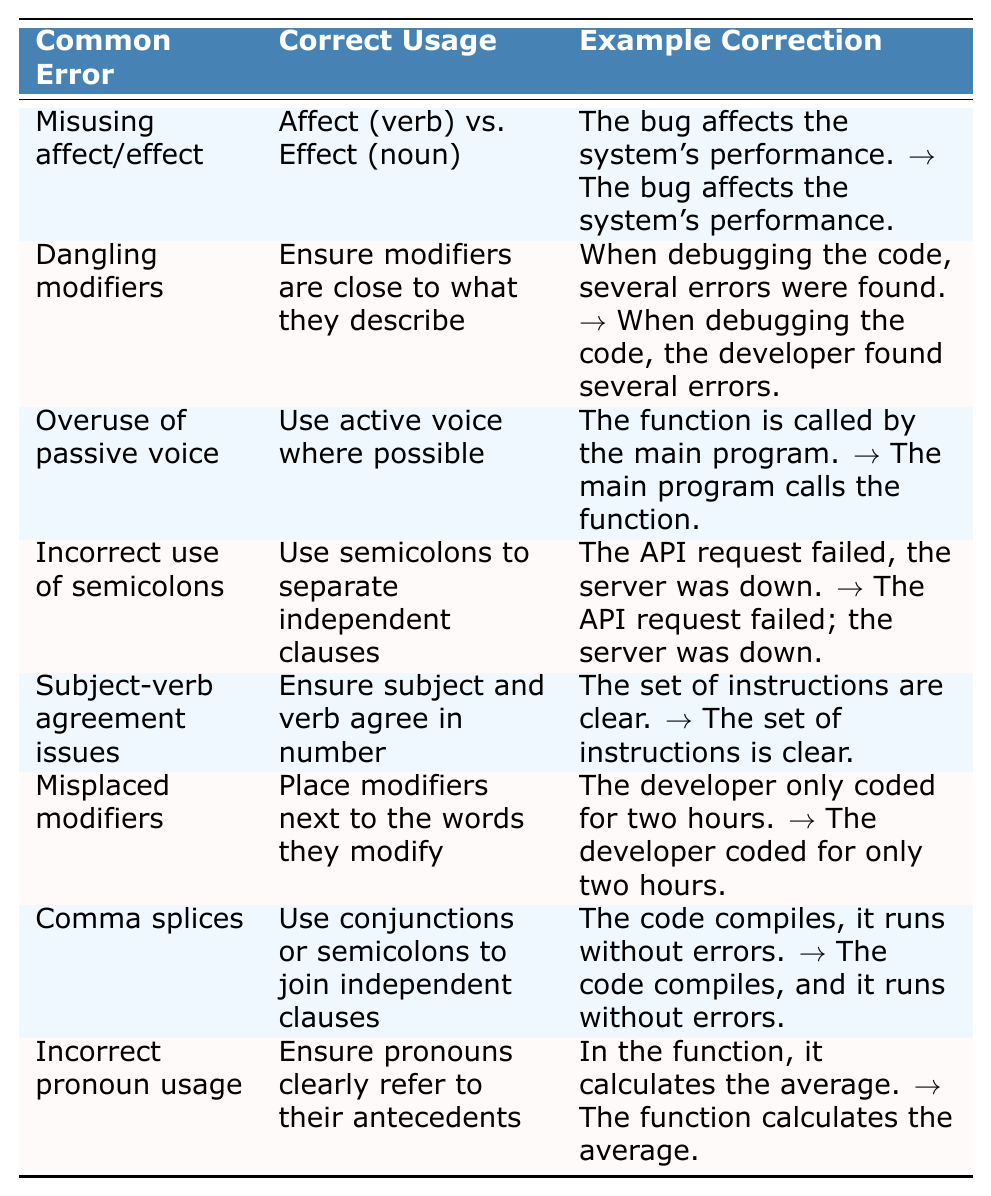What is the common error associated with using "affect" and "effect"? The table lists "Misusing affect/effect" as the common error related to these terms.
Answer: Misusing affect/effect What is the correct usage for dangling modifiers? The table indicates that the correct usage is to ensure modifiers are close to what they describe.
Answer: Ensure modifiers are close to what they describe Which error addresses the issues with subject-verb agreement? The table clearly shows "Subject-verb agreement issues" as the relevant error for this topic.
Answer: Subject-verb agreement issues How many examples are provided for incorrect pronoun usage? The table provides one specific example for "Incorrect pronoun usage," indicating that it is a singular case.
Answer: One example What correction is given for the error with comma splices? The table states that the correction is to use conjunctions or semicolons to join independent clauses.
Answer: Use conjunctions or semicolons to join independent clauses Is overuse of passive voice identified as a common error? Yes, the table includes "Overuse of passive voice" as a common error in technical writing.
Answer: Yes Can you identify the correct usage provided for the misplacement of modifiers? The table advises that modifiers should be placed next to the words they modify to avoid misplacement.
Answer: Place modifiers next to the words they modify What correction is suggested for the incorrect use of semicolons? The correction suggests using semicolons to separate independent clauses instead of incorrectly using commas.
Answer: Use semicolons to separate independent clauses Which common error involves issues with clarity in pronoun usage? The error listed is "Incorrect pronoun usage," which addresses issues with clarity.
Answer: Incorrect pronoun usage What is the common error associated with passive voice? The common error associated with passive voice is stated as "Overuse of passive voice" in the table.
Answer: Overuse of passive voice Which correction addresses the problem of dangling modifiers? The correction for dangling modifiers is to ensure the modifiers are close to what they describe.
Answer: Ensure modifiers are close to what they describe Are there more examples related to misuse of affect/effect or dangling modifiers? The table shows that both errors have one example each, so they are equal in the number of examples provided.
Answer: Equal number of examples For the error "Incorrect use of semicolons," how is it corrected according to the table? The error is corrected by using semicolons to separate independent clauses correctly.
Answer: Use semicolons to separate independent clauses Which common error has the explanation to "Use active voice where possible"? The table indicates that "Overuse of passive voice" has this explanation.
Answer: Overuse of passive voice What is the correct usage for subject-verb agreement issues? The correct usage is to ensure that the subject and verb agree in number according to the table.
Answer: Ensure subject and verb agree in number How many discrete errors are listed in the table? The table contains a total of eight discrete grammatical errors commonly found in technical writing.
Answer: Eight errors What common grammatical issue involves using "it" ambiguously? The common issue is identified as "Incorrect pronoun usage."
Answer: Incorrect pronoun usage 